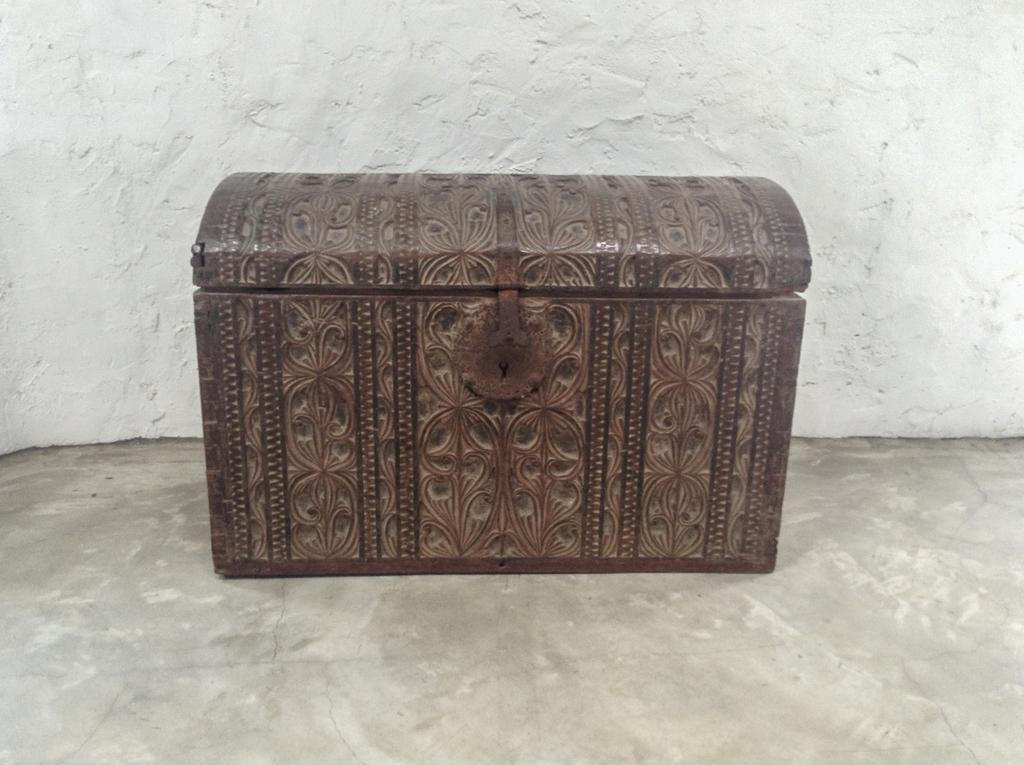Describe this image in one or two sentences. In the center of the image, we can see a trunk box placed on the floor and in the background, there is a wall. 